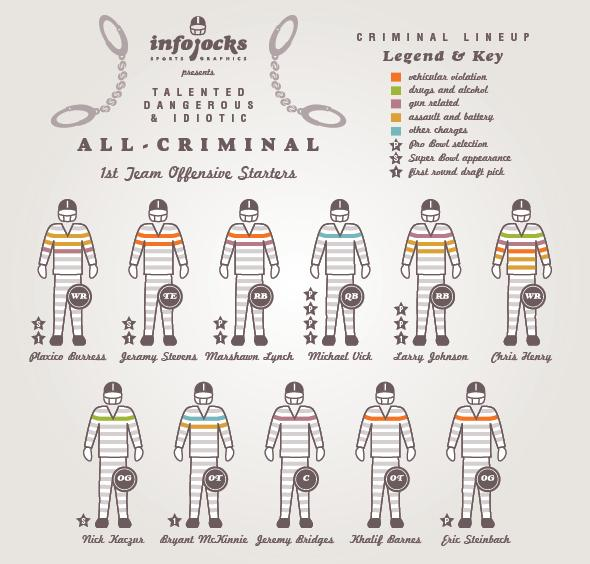List a handful of essential elements in this visual. Khalid Barnes was charged with a violation of vehicular law. The players named as those selected to participate in the Super Bowl and selected in the first round of the draft are Plaxico Burress and Jeramy Stevens. I, Michael Vick, have been selected for the Pro Bowl three times, marking me as a standout player in my field. The offenses registered against Marshawn Lynch include vehicular violations and gun-related incidents. The following individuals have registered for drug and alcohol-related charges: Chris Henry and Nick Kaczur. 